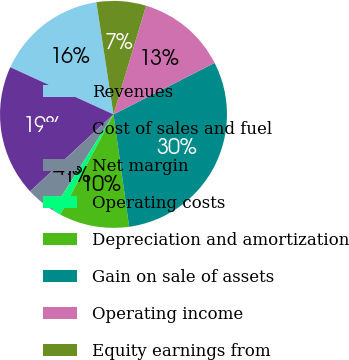<chart> <loc_0><loc_0><loc_500><loc_500><pie_chart><fcel>Revenues<fcel>Cost of sales and fuel<fcel>Net margin<fcel>Operating costs<fcel>Depreciation and amortization<fcel>Gain on sale of assets<fcel>Operating income<fcel>Equity earnings from<nl><fcel>15.77%<fcel>18.68%<fcel>4.14%<fcel>1.24%<fcel>9.96%<fcel>30.3%<fcel>12.86%<fcel>7.05%<nl></chart> 